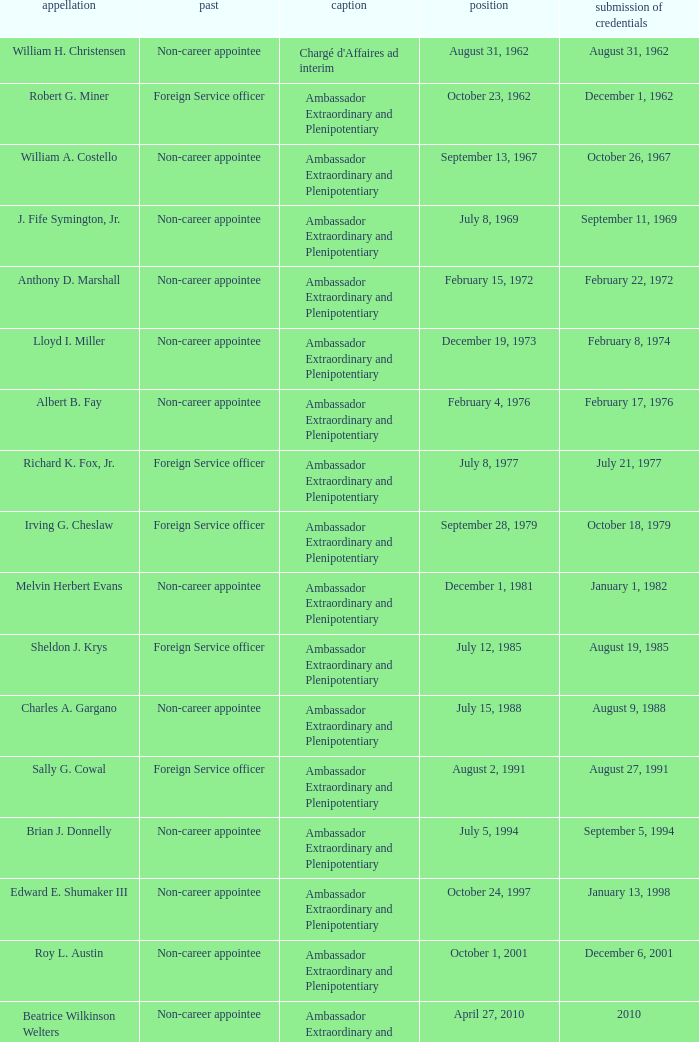When did Robert G. Miner present his credentials? December 1, 1962. 